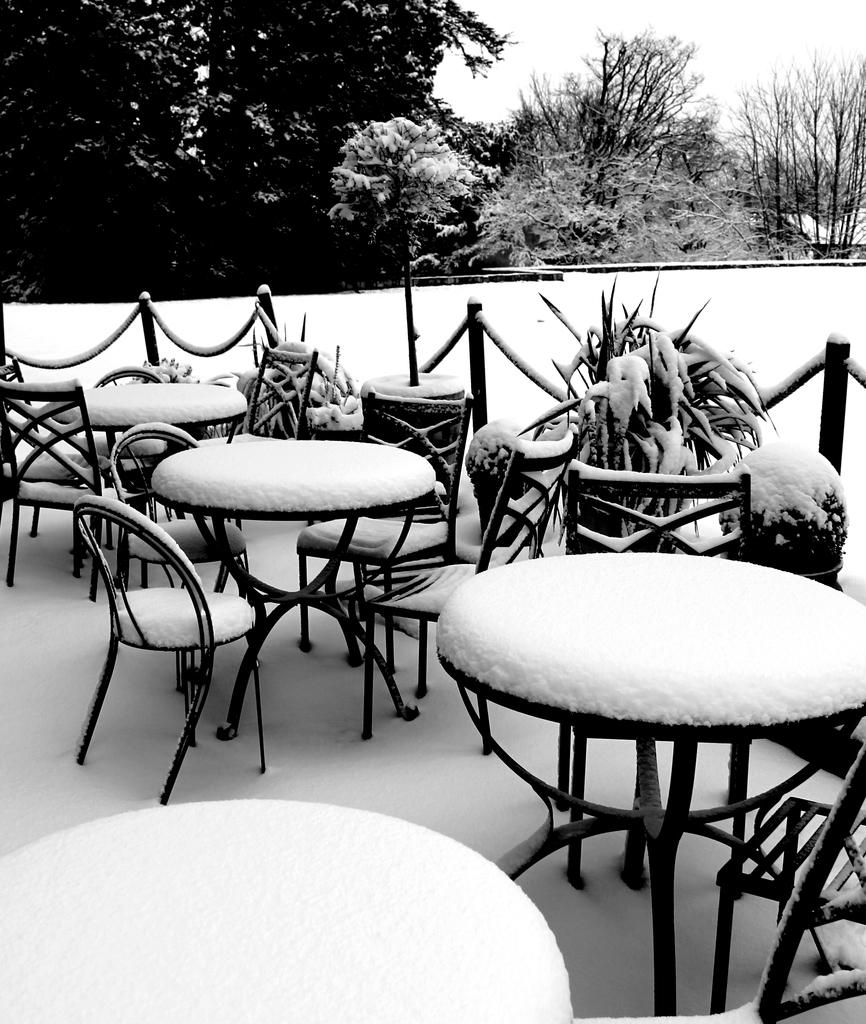What type of furniture is present in the image? There are tables and chairs in the image. What can be seen in the background of the image? Trees are visible in the background of the image. What is the condition of the ground in the middle of the image? The image appears to depict snow in the middle. What is the color scheme of the image? The image is in black and white. How do the brothers interact with the government in the image? There are no brothers or government present in the image. What is the digestion process of the trees in the image? The image does not depict the digestion process of the trees; it only shows the trees in the background. 